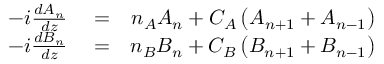<formula> <loc_0><loc_0><loc_500><loc_500>\begin{array} { r l r } { - i \frac { d A _ { n } } { d z } } & = } & { n _ { A } A _ { n } + C _ { A } \left ( A _ { n + 1 } + A _ { n - 1 } \right ) } \\ { - i \frac { d B _ { n } } { d z } } & = } & { n _ { B } B _ { n } + C _ { B } \left ( B _ { n + 1 } + B _ { n - 1 } \right ) } \end{array}</formula> 